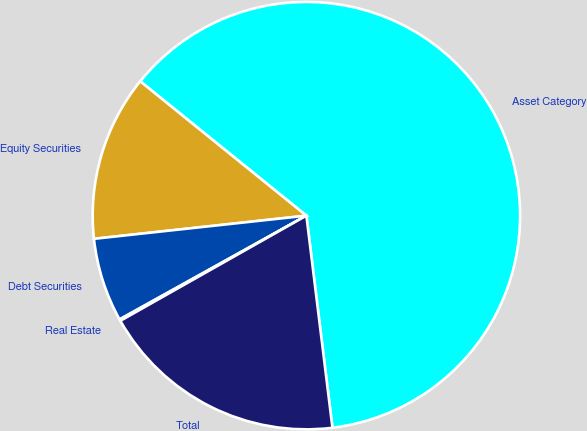Convert chart. <chart><loc_0><loc_0><loc_500><loc_500><pie_chart><fcel>Asset Category<fcel>Equity Securities<fcel>Debt Securities<fcel>Real Estate<fcel>Total<nl><fcel>62.24%<fcel>12.55%<fcel>6.34%<fcel>0.12%<fcel>18.76%<nl></chart> 